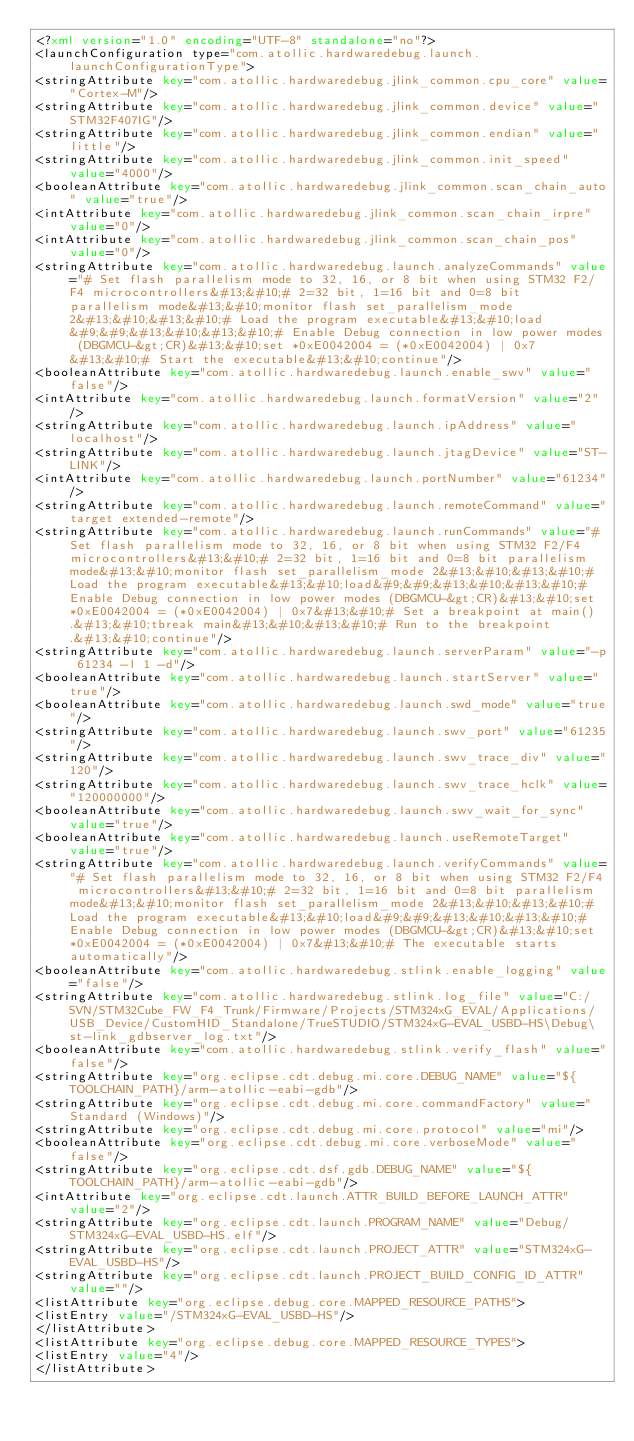Convert code to text. <code><loc_0><loc_0><loc_500><loc_500><_XML_><?xml version="1.0" encoding="UTF-8" standalone="no"?>
<launchConfiguration type="com.atollic.hardwaredebug.launch.launchConfigurationType">
<stringAttribute key="com.atollic.hardwaredebug.jlink_common.cpu_core" value="Cortex-M"/>
<stringAttribute key="com.atollic.hardwaredebug.jlink_common.device" value="STM32F407IG"/>
<stringAttribute key="com.atollic.hardwaredebug.jlink_common.endian" value="little"/>
<stringAttribute key="com.atollic.hardwaredebug.jlink_common.init_speed" value="4000"/>
<booleanAttribute key="com.atollic.hardwaredebug.jlink_common.scan_chain_auto" value="true"/>
<intAttribute key="com.atollic.hardwaredebug.jlink_common.scan_chain_irpre" value="0"/>
<intAttribute key="com.atollic.hardwaredebug.jlink_common.scan_chain_pos" value="0"/>
<stringAttribute key="com.atollic.hardwaredebug.launch.analyzeCommands" value="# Set flash parallelism mode to 32, 16, or 8 bit when using STM32 F2/F4 microcontrollers&#13;&#10;# 2=32 bit, 1=16 bit and 0=8 bit parallelism mode&#13;&#10;monitor flash set_parallelism_mode 2&#13;&#10;&#13;&#10;# Load the program executable&#13;&#10;load&#9;&#9;&#13;&#10;&#13;&#10;# Enable Debug connection in low power modes (DBGMCU-&gt;CR)&#13;&#10;set *0xE0042004 = (*0xE0042004) | 0x7&#13;&#10;# Start the executable&#13;&#10;continue"/>
<booleanAttribute key="com.atollic.hardwaredebug.launch.enable_swv" value="false"/>
<intAttribute key="com.atollic.hardwaredebug.launch.formatVersion" value="2"/>
<stringAttribute key="com.atollic.hardwaredebug.launch.ipAddress" value="localhost"/>
<stringAttribute key="com.atollic.hardwaredebug.launch.jtagDevice" value="ST-LINK"/>
<intAttribute key="com.atollic.hardwaredebug.launch.portNumber" value="61234"/>
<stringAttribute key="com.atollic.hardwaredebug.launch.remoteCommand" value="target extended-remote"/>
<stringAttribute key="com.atollic.hardwaredebug.launch.runCommands" value="# Set flash parallelism mode to 32, 16, or 8 bit when using STM32 F2/F4 microcontrollers&#13;&#10;# 2=32 bit, 1=16 bit and 0=8 bit parallelism mode&#13;&#10;monitor flash set_parallelism_mode 2&#13;&#10;&#13;&#10;# Load the program executable&#13;&#10;load&#9;&#9;&#13;&#10;&#13;&#10;# Enable Debug connection in low power modes (DBGMCU-&gt;CR)&#13;&#10;set *0xE0042004 = (*0xE0042004) | 0x7&#13;&#10;# Set a breakpoint at main().&#13;&#10;tbreak main&#13;&#10;&#13;&#10;# Run to the breakpoint.&#13;&#10;continue"/>
<stringAttribute key="com.atollic.hardwaredebug.launch.serverParam" value="-p 61234 -l 1 -d"/>
<booleanAttribute key="com.atollic.hardwaredebug.launch.startServer" value="true"/>
<booleanAttribute key="com.atollic.hardwaredebug.launch.swd_mode" value="true"/>
<stringAttribute key="com.atollic.hardwaredebug.launch.swv_port" value="61235"/>
<stringAttribute key="com.atollic.hardwaredebug.launch.swv_trace_div" value="120"/>
<stringAttribute key="com.atollic.hardwaredebug.launch.swv_trace_hclk" value="120000000"/>
<booleanAttribute key="com.atollic.hardwaredebug.launch.swv_wait_for_sync" value="true"/>
<booleanAttribute key="com.atollic.hardwaredebug.launch.useRemoteTarget" value="true"/>
<stringAttribute key="com.atollic.hardwaredebug.launch.verifyCommands" value="# Set flash parallelism mode to 32, 16, or 8 bit when using STM32 F2/F4 microcontrollers&#13;&#10;# 2=32 bit, 1=16 bit and 0=8 bit parallelism mode&#13;&#10;monitor flash set_parallelism_mode 2&#13;&#10;&#13;&#10;# Load the program executable&#13;&#10;load&#9;&#9;&#13;&#10;&#13;&#10;# Enable Debug connection in low power modes (DBGMCU-&gt;CR)&#13;&#10;set *0xE0042004 = (*0xE0042004) | 0x7&#13;&#10;# The executable starts automatically"/>
<booleanAttribute key="com.atollic.hardwaredebug.stlink.enable_logging" value="false"/>
<stringAttribute key="com.atollic.hardwaredebug.stlink.log_file" value="C:/SVN/STM32Cube_FW_F4_Trunk/Firmware/Projects/STM324xG_EVAL/Applications/USB_Device/CustomHID_Standalone/TrueSTUDIO/STM324xG-EVAL_USBD-HS\Debug\st-link_gdbserver_log.txt"/>
<booleanAttribute key="com.atollic.hardwaredebug.stlink.verify_flash" value="false"/>
<stringAttribute key="org.eclipse.cdt.debug.mi.core.DEBUG_NAME" value="${TOOLCHAIN_PATH}/arm-atollic-eabi-gdb"/>
<stringAttribute key="org.eclipse.cdt.debug.mi.core.commandFactory" value="Standard (Windows)"/>
<stringAttribute key="org.eclipse.cdt.debug.mi.core.protocol" value="mi"/>
<booleanAttribute key="org.eclipse.cdt.debug.mi.core.verboseMode" value="false"/>
<stringAttribute key="org.eclipse.cdt.dsf.gdb.DEBUG_NAME" value="${TOOLCHAIN_PATH}/arm-atollic-eabi-gdb"/>
<intAttribute key="org.eclipse.cdt.launch.ATTR_BUILD_BEFORE_LAUNCH_ATTR" value="2"/>
<stringAttribute key="org.eclipse.cdt.launch.PROGRAM_NAME" value="Debug/STM324xG-EVAL_USBD-HS.elf"/>
<stringAttribute key="org.eclipse.cdt.launch.PROJECT_ATTR" value="STM324xG-EVAL_USBD-HS"/>
<stringAttribute key="org.eclipse.cdt.launch.PROJECT_BUILD_CONFIG_ID_ATTR" value=""/>
<listAttribute key="org.eclipse.debug.core.MAPPED_RESOURCE_PATHS">
<listEntry value="/STM324xG-EVAL_USBD-HS"/>
</listAttribute>
<listAttribute key="org.eclipse.debug.core.MAPPED_RESOURCE_TYPES">
<listEntry value="4"/>
</listAttribute></code> 